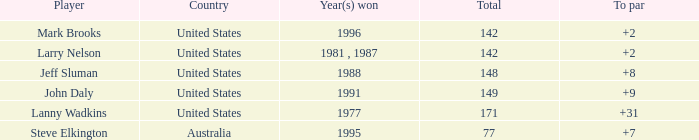Can you give me this table as a dict? {'header': ['Player', 'Country', 'Year(s) won', 'Total', 'To par'], 'rows': [['Mark Brooks', 'United States', '1996', '142', '+2'], ['Larry Nelson', 'United States', '1981 , 1987', '142', '+2'], ['Jeff Sluman', 'United States', '1988', '148', '+8'], ['John Daly', 'United States', '1991', '149', '+9'], ['Lanny Wadkins', 'United States', '1977', '171', '+31'], ['Steve Elkington', 'Australia', '1995', '77', '+7']]} Who is the winner from 1988 with a total below 148? None. 